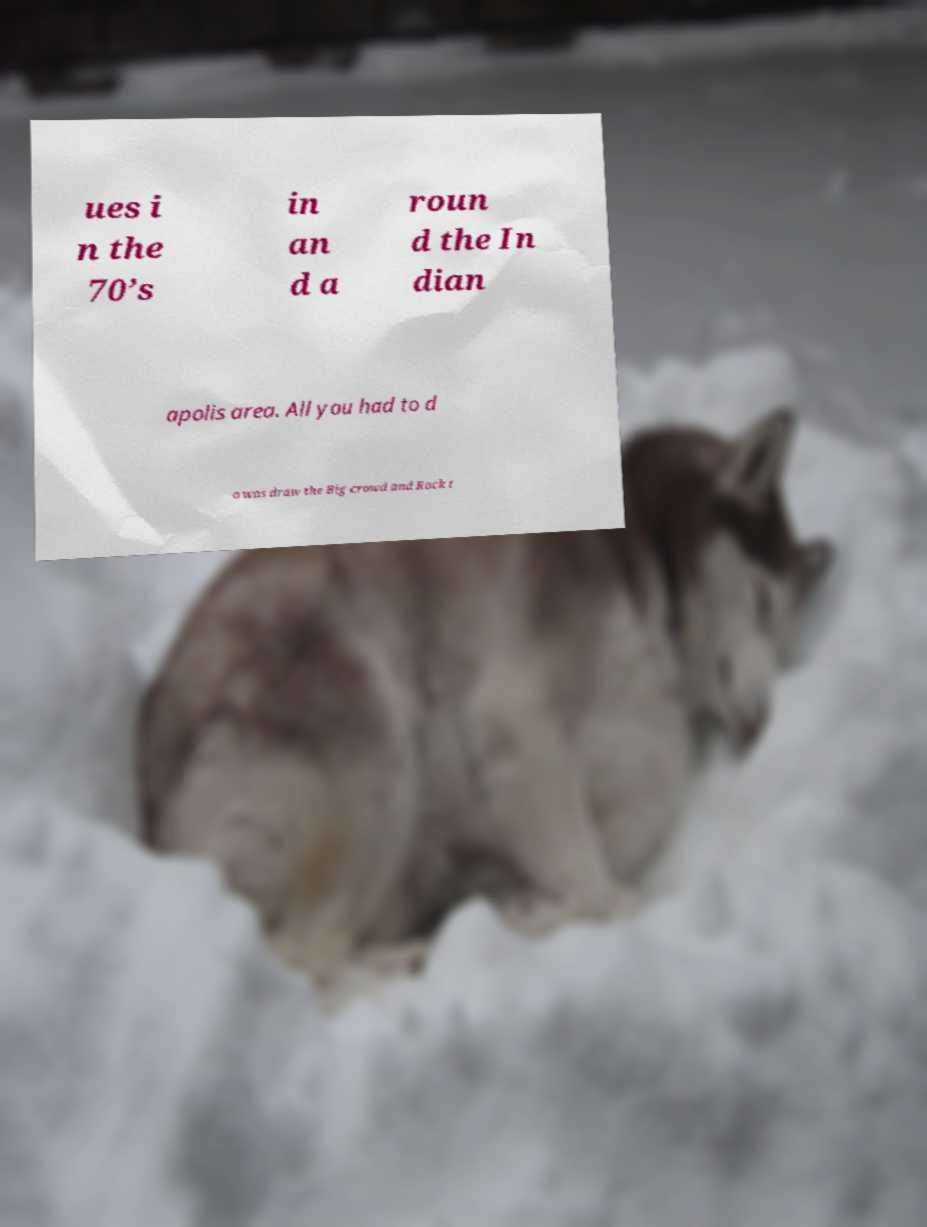What messages or text are displayed in this image? I need them in a readable, typed format. ues i n the 70’s in an d a roun d the In dian apolis area. All you had to d o was draw the Big crowd and Rock t 